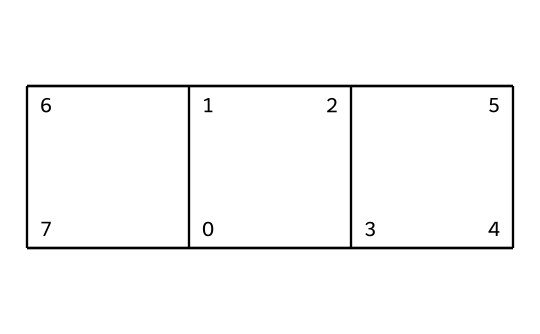How many carbon atoms are in adamantane? The SMILES representation reveals a structure with the connectivity of carbon atoms. Counting the 'C' symbols shows there are 10 carbon atoms present.
Answer: 10 What type of compound is adamantane? The characteristics of the chemical structure in the SMILES notation point to adamantane being a cage compound, as it consists of a polycyclic arrangement of carbon atoms.
Answer: cage compound What is the molecular formula of adamantane? From the SMILES, we identify that adamantane consists of 10 carbon atoms and 16 hydrogen atoms (C10H16) as it follows typical saturation rules.
Answer: C10H16 How many hydrogen atoms are bonded to each carbon in adamantane? Considering the structure and bonding patterns typical of cage compounds, each of the 10 carbon atoms in adamantane is bonded to 2 hydrogen atoms on average due to its tetravalent nature and the interconnected framework.
Answer: 2 What is the significance of the cage structure in adamantane? The cage structure allows adamantane to have unique properties compared to linear hydrocarbons, including stability and the ability to be utilized in pharmaceuticals, such as cold medications.
Answer: stability How many rings are present in the structure of adamantane? Examining the interconnected cyclic framework of adamantane shows that it consists of four fused cyclohexane rings, characteristic of its cage structure.
Answer: 4 What type of bonding is primarily present in the structure of adamantane? The compound is predominantly composed of covalent bonds, as seen from the carbon-carbon bonds connecting the atoms in the cage-like appearance of the structure.
Answer: covalent bonds 